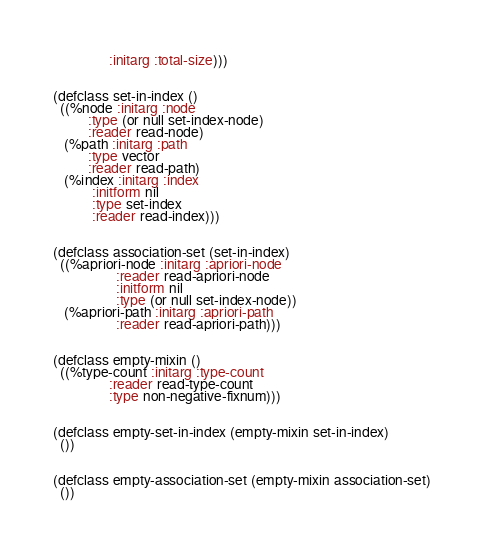Convert code to text. <code><loc_0><loc_0><loc_500><loc_500><_Lisp_>                :initarg :total-size)))


(defclass set-in-index ()
  ((%node :initarg :node
          :type (or null set-index-node)
          :reader read-node)
   (%path :initarg :path
          :type vector
          :reader read-path)
   (%index :initarg :index
           :initform nil
           :type set-index
           :reader read-index)))


(defclass association-set (set-in-index)
  ((%apriori-node :initarg :apriori-node
                  :reader read-apriori-node
                  :initform nil
                  :type (or null set-index-node))
   (%apriori-path :initarg :apriori-path
                  :reader read-apriori-path)))


(defclass empty-mixin ()
  ((%type-count :initarg :type-count
                :reader read-type-count
                :type non-negative-fixnum)))


(defclass empty-set-in-index (empty-mixin set-in-index)
  ())


(defclass empty-association-set (empty-mixin association-set)
  ())
</code> 